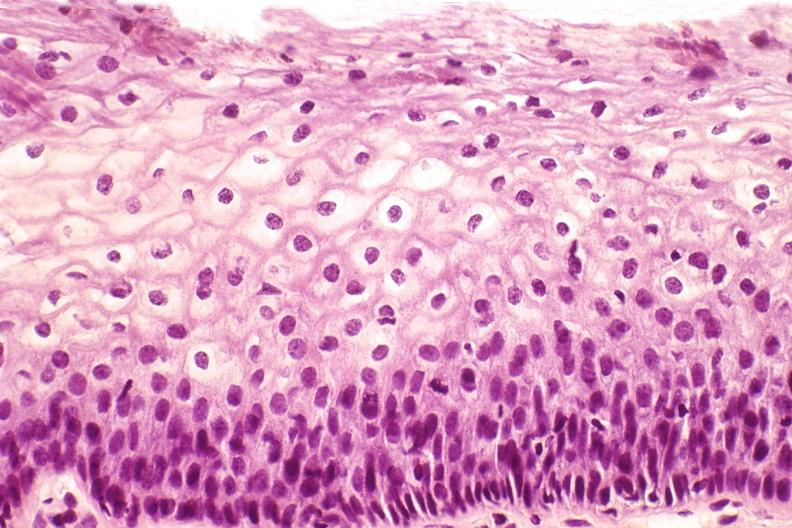does lesion in dome of uterus show cervix, mild dysplasia?
Answer the question using a single word or phrase. No 